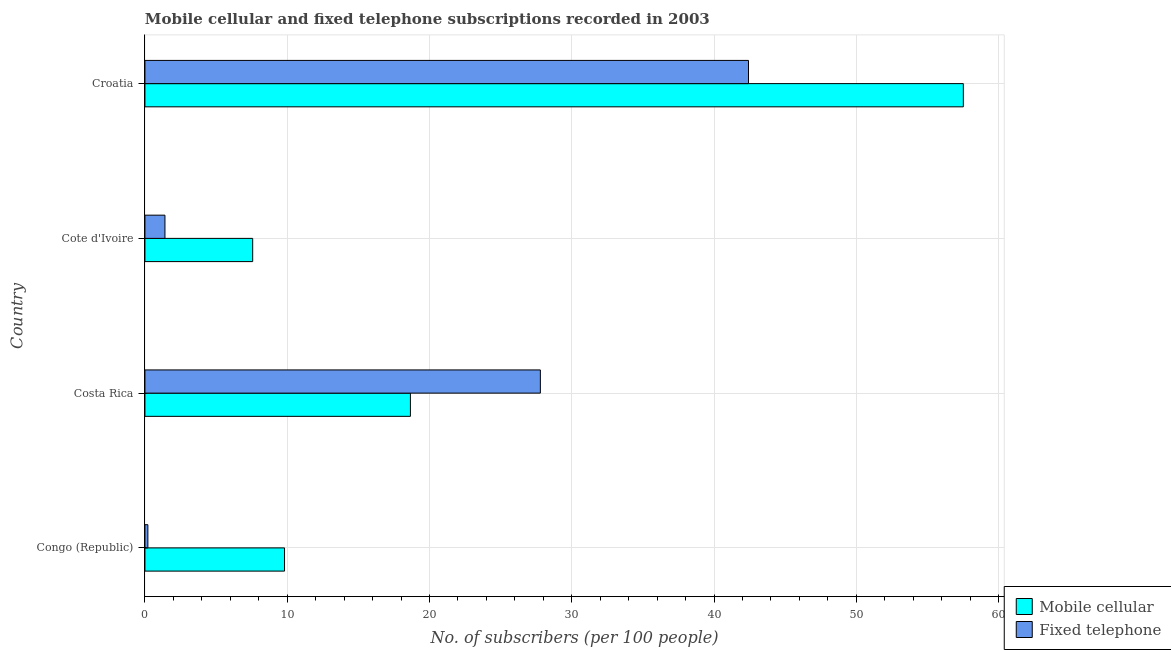How many different coloured bars are there?
Keep it short and to the point. 2. Are the number of bars per tick equal to the number of legend labels?
Offer a very short reply. Yes. Are the number of bars on each tick of the Y-axis equal?
Give a very brief answer. Yes. How many bars are there on the 2nd tick from the top?
Provide a short and direct response. 2. How many bars are there on the 2nd tick from the bottom?
Ensure brevity in your answer.  2. What is the label of the 3rd group of bars from the top?
Provide a short and direct response. Costa Rica. In how many cases, is the number of bars for a given country not equal to the number of legend labels?
Your response must be concise. 0. What is the number of mobile cellular subscribers in Croatia?
Provide a short and direct response. 57.52. Across all countries, what is the maximum number of fixed telephone subscribers?
Provide a succinct answer. 42.42. Across all countries, what is the minimum number of mobile cellular subscribers?
Your answer should be very brief. 7.57. In which country was the number of fixed telephone subscribers maximum?
Your answer should be very brief. Croatia. In which country was the number of fixed telephone subscribers minimum?
Your answer should be compact. Congo (Republic). What is the total number of mobile cellular subscribers in the graph?
Give a very brief answer. 93.56. What is the difference between the number of mobile cellular subscribers in Congo (Republic) and that in Cote d'Ivoire?
Give a very brief answer. 2.24. What is the difference between the number of fixed telephone subscribers in Costa Rica and the number of mobile cellular subscribers in Croatia?
Your response must be concise. -29.73. What is the average number of fixed telephone subscribers per country?
Offer a terse response. 17.96. What is the difference between the number of mobile cellular subscribers and number of fixed telephone subscribers in Costa Rica?
Ensure brevity in your answer.  -9.13. In how many countries, is the number of mobile cellular subscribers greater than 24 ?
Your answer should be compact. 1. What is the ratio of the number of fixed telephone subscribers in Cote d'Ivoire to that in Croatia?
Make the answer very short. 0.03. What is the difference between the highest and the second highest number of mobile cellular subscribers?
Provide a short and direct response. 38.86. What is the difference between the highest and the lowest number of fixed telephone subscribers?
Offer a terse response. 42.21. In how many countries, is the number of fixed telephone subscribers greater than the average number of fixed telephone subscribers taken over all countries?
Offer a very short reply. 2. Is the sum of the number of mobile cellular subscribers in Cote d'Ivoire and Croatia greater than the maximum number of fixed telephone subscribers across all countries?
Your answer should be compact. Yes. What does the 1st bar from the top in Cote d'Ivoire represents?
Give a very brief answer. Fixed telephone. What does the 1st bar from the bottom in Cote d'Ivoire represents?
Make the answer very short. Mobile cellular. Are all the bars in the graph horizontal?
Provide a succinct answer. Yes. How many countries are there in the graph?
Ensure brevity in your answer.  4. What is the difference between two consecutive major ticks on the X-axis?
Offer a very short reply. 10. Are the values on the major ticks of X-axis written in scientific E-notation?
Offer a very short reply. No. Does the graph contain grids?
Provide a short and direct response. Yes. Where does the legend appear in the graph?
Make the answer very short. Bottom right. How are the legend labels stacked?
Your response must be concise. Vertical. What is the title of the graph?
Provide a short and direct response. Mobile cellular and fixed telephone subscriptions recorded in 2003. What is the label or title of the X-axis?
Your answer should be compact. No. of subscribers (per 100 people). What is the label or title of the Y-axis?
Your response must be concise. Country. What is the No. of subscribers (per 100 people) of Mobile cellular in Congo (Republic)?
Give a very brief answer. 9.81. What is the No. of subscribers (per 100 people) of Fixed telephone in Congo (Republic)?
Your answer should be very brief. 0.21. What is the No. of subscribers (per 100 people) in Mobile cellular in Costa Rica?
Offer a very short reply. 18.66. What is the No. of subscribers (per 100 people) in Fixed telephone in Costa Rica?
Your answer should be compact. 27.79. What is the No. of subscribers (per 100 people) in Mobile cellular in Cote d'Ivoire?
Ensure brevity in your answer.  7.57. What is the No. of subscribers (per 100 people) in Fixed telephone in Cote d'Ivoire?
Your response must be concise. 1.41. What is the No. of subscribers (per 100 people) of Mobile cellular in Croatia?
Your answer should be compact. 57.52. What is the No. of subscribers (per 100 people) of Fixed telephone in Croatia?
Ensure brevity in your answer.  42.42. Across all countries, what is the maximum No. of subscribers (per 100 people) of Mobile cellular?
Your answer should be compact. 57.52. Across all countries, what is the maximum No. of subscribers (per 100 people) of Fixed telephone?
Ensure brevity in your answer.  42.42. Across all countries, what is the minimum No. of subscribers (per 100 people) of Mobile cellular?
Provide a short and direct response. 7.57. Across all countries, what is the minimum No. of subscribers (per 100 people) in Fixed telephone?
Your answer should be compact. 0.21. What is the total No. of subscribers (per 100 people) of Mobile cellular in the graph?
Offer a very short reply. 93.56. What is the total No. of subscribers (per 100 people) of Fixed telephone in the graph?
Provide a succinct answer. 71.83. What is the difference between the No. of subscribers (per 100 people) of Mobile cellular in Congo (Republic) and that in Costa Rica?
Make the answer very short. -8.85. What is the difference between the No. of subscribers (per 100 people) in Fixed telephone in Congo (Republic) and that in Costa Rica?
Give a very brief answer. -27.58. What is the difference between the No. of subscribers (per 100 people) of Mobile cellular in Congo (Republic) and that in Cote d'Ivoire?
Provide a short and direct response. 2.24. What is the difference between the No. of subscribers (per 100 people) in Fixed telephone in Congo (Republic) and that in Cote d'Ivoire?
Ensure brevity in your answer.  -1.2. What is the difference between the No. of subscribers (per 100 people) in Mobile cellular in Congo (Republic) and that in Croatia?
Ensure brevity in your answer.  -47.71. What is the difference between the No. of subscribers (per 100 people) in Fixed telephone in Congo (Republic) and that in Croatia?
Offer a very short reply. -42.21. What is the difference between the No. of subscribers (per 100 people) of Mobile cellular in Costa Rica and that in Cote d'Ivoire?
Offer a very short reply. 11.09. What is the difference between the No. of subscribers (per 100 people) in Fixed telephone in Costa Rica and that in Cote d'Ivoire?
Provide a short and direct response. 26.38. What is the difference between the No. of subscribers (per 100 people) in Mobile cellular in Costa Rica and that in Croatia?
Provide a succinct answer. -38.86. What is the difference between the No. of subscribers (per 100 people) in Fixed telephone in Costa Rica and that in Croatia?
Provide a succinct answer. -14.63. What is the difference between the No. of subscribers (per 100 people) in Mobile cellular in Cote d'Ivoire and that in Croatia?
Provide a short and direct response. -49.94. What is the difference between the No. of subscribers (per 100 people) in Fixed telephone in Cote d'Ivoire and that in Croatia?
Ensure brevity in your answer.  -41.01. What is the difference between the No. of subscribers (per 100 people) in Mobile cellular in Congo (Republic) and the No. of subscribers (per 100 people) in Fixed telephone in Costa Rica?
Make the answer very short. -17.98. What is the difference between the No. of subscribers (per 100 people) in Mobile cellular in Congo (Republic) and the No. of subscribers (per 100 people) in Fixed telephone in Cote d'Ivoire?
Give a very brief answer. 8.4. What is the difference between the No. of subscribers (per 100 people) in Mobile cellular in Congo (Republic) and the No. of subscribers (per 100 people) in Fixed telephone in Croatia?
Your answer should be very brief. -32.61. What is the difference between the No. of subscribers (per 100 people) of Mobile cellular in Costa Rica and the No. of subscribers (per 100 people) of Fixed telephone in Cote d'Ivoire?
Give a very brief answer. 17.25. What is the difference between the No. of subscribers (per 100 people) in Mobile cellular in Costa Rica and the No. of subscribers (per 100 people) in Fixed telephone in Croatia?
Provide a short and direct response. -23.76. What is the difference between the No. of subscribers (per 100 people) of Mobile cellular in Cote d'Ivoire and the No. of subscribers (per 100 people) of Fixed telephone in Croatia?
Offer a terse response. -34.85. What is the average No. of subscribers (per 100 people) in Mobile cellular per country?
Ensure brevity in your answer.  23.39. What is the average No. of subscribers (per 100 people) in Fixed telephone per country?
Offer a very short reply. 17.96. What is the difference between the No. of subscribers (per 100 people) in Mobile cellular and No. of subscribers (per 100 people) in Fixed telephone in Congo (Republic)?
Give a very brief answer. 9.6. What is the difference between the No. of subscribers (per 100 people) in Mobile cellular and No. of subscribers (per 100 people) in Fixed telephone in Costa Rica?
Ensure brevity in your answer.  -9.13. What is the difference between the No. of subscribers (per 100 people) of Mobile cellular and No. of subscribers (per 100 people) of Fixed telephone in Cote d'Ivoire?
Your response must be concise. 6.17. What is the difference between the No. of subscribers (per 100 people) of Mobile cellular and No. of subscribers (per 100 people) of Fixed telephone in Croatia?
Provide a short and direct response. 15.1. What is the ratio of the No. of subscribers (per 100 people) of Mobile cellular in Congo (Republic) to that in Costa Rica?
Provide a succinct answer. 0.53. What is the ratio of the No. of subscribers (per 100 people) of Fixed telephone in Congo (Republic) to that in Costa Rica?
Offer a terse response. 0.01. What is the ratio of the No. of subscribers (per 100 people) of Mobile cellular in Congo (Republic) to that in Cote d'Ivoire?
Your answer should be very brief. 1.3. What is the ratio of the No. of subscribers (per 100 people) of Fixed telephone in Congo (Republic) to that in Cote d'Ivoire?
Your answer should be very brief. 0.15. What is the ratio of the No. of subscribers (per 100 people) of Mobile cellular in Congo (Republic) to that in Croatia?
Make the answer very short. 0.17. What is the ratio of the No. of subscribers (per 100 people) of Fixed telephone in Congo (Republic) to that in Croatia?
Ensure brevity in your answer.  0. What is the ratio of the No. of subscribers (per 100 people) in Mobile cellular in Costa Rica to that in Cote d'Ivoire?
Offer a terse response. 2.46. What is the ratio of the No. of subscribers (per 100 people) in Fixed telephone in Costa Rica to that in Cote d'Ivoire?
Your answer should be very brief. 19.75. What is the ratio of the No. of subscribers (per 100 people) of Mobile cellular in Costa Rica to that in Croatia?
Your answer should be compact. 0.32. What is the ratio of the No. of subscribers (per 100 people) in Fixed telephone in Costa Rica to that in Croatia?
Offer a terse response. 0.66. What is the ratio of the No. of subscribers (per 100 people) in Mobile cellular in Cote d'Ivoire to that in Croatia?
Offer a very short reply. 0.13. What is the ratio of the No. of subscribers (per 100 people) of Fixed telephone in Cote d'Ivoire to that in Croatia?
Make the answer very short. 0.03. What is the difference between the highest and the second highest No. of subscribers (per 100 people) of Mobile cellular?
Make the answer very short. 38.86. What is the difference between the highest and the second highest No. of subscribers (per 100 people) of Fixed telephone?
Provide a short and direct response. 14.63. What is the difference between the highest and the lowest No. of subscribers (per 100 people) in Mobile cellular?
Provide a short and direct response. 49.94. What is the difference between the highest and the lowest No. of subscribers (per 100 people) of Fixed telephone?
Keep it short and to the point. 42.21. 